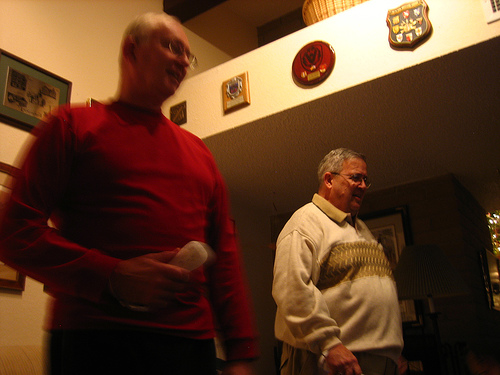Are there any batteries or girls? In the visible portions of the image, there are neither batteries nor girls present. 